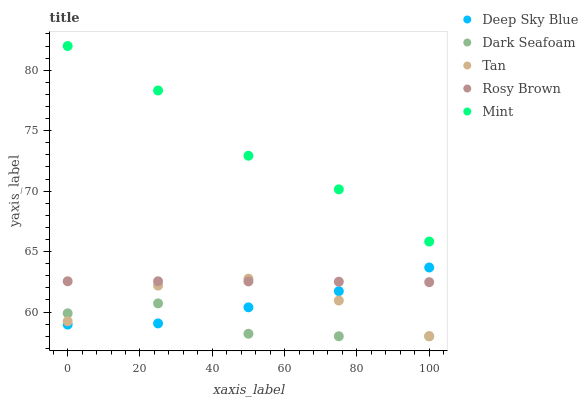Does Dark Seafoam have the minimum area under the curve?
Answer yes or no. Yes. Does Mint have the maximum area under the curve?
Answer yes or no. Yes. Does Rosy Brown have the minimum area under the curve?
Answer yes or no. No. Does Rosy Brown have the maximum area under the curve?
Answer yes or no. No. Is Rosy Brown the smoothest?
Answer yes or no. Yes. Is Tan the roughest?
Answer yes or no. Yes. Is Mint the smoothest?
Answer yes or no. No. Is Mint the roughest?
Answer yes or no. No. Does Dark Seafoam have the lowest value?
Answer yes or no. Yes. Does Rosy Brown have the lowest value?
Answer yes or no. No. Does Mint have the highest value?
Answer yes or no. Yes. Does Rosy Brown have the highest value?
Answer yes or no. No. Is Dark Seafoam less than Mint?
Answer yes or no. Yes. Is Mint greater than Tan?
Answer yes or no. Yes. Does Rosy Brown intersect Deep Sky Blue?
Answer yes or no. Yes. Is Rosy Brown less than Deep Sky Blue?
Answer yes or no. No. Is Rosy Brown greater than Deep Sky Blue?
Answer yes or no. No. Does Dark Seafoam intersect Mint?
Answer yes or no. No. 